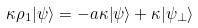<formula> <loc_0><loc_0><loc_500><loc_500>\kappa \rho _ { 1 } | \psi \rangle = - a \kappa | \psi \rangle + \kappa | \psi _ { \bot } \rangle</formula> 